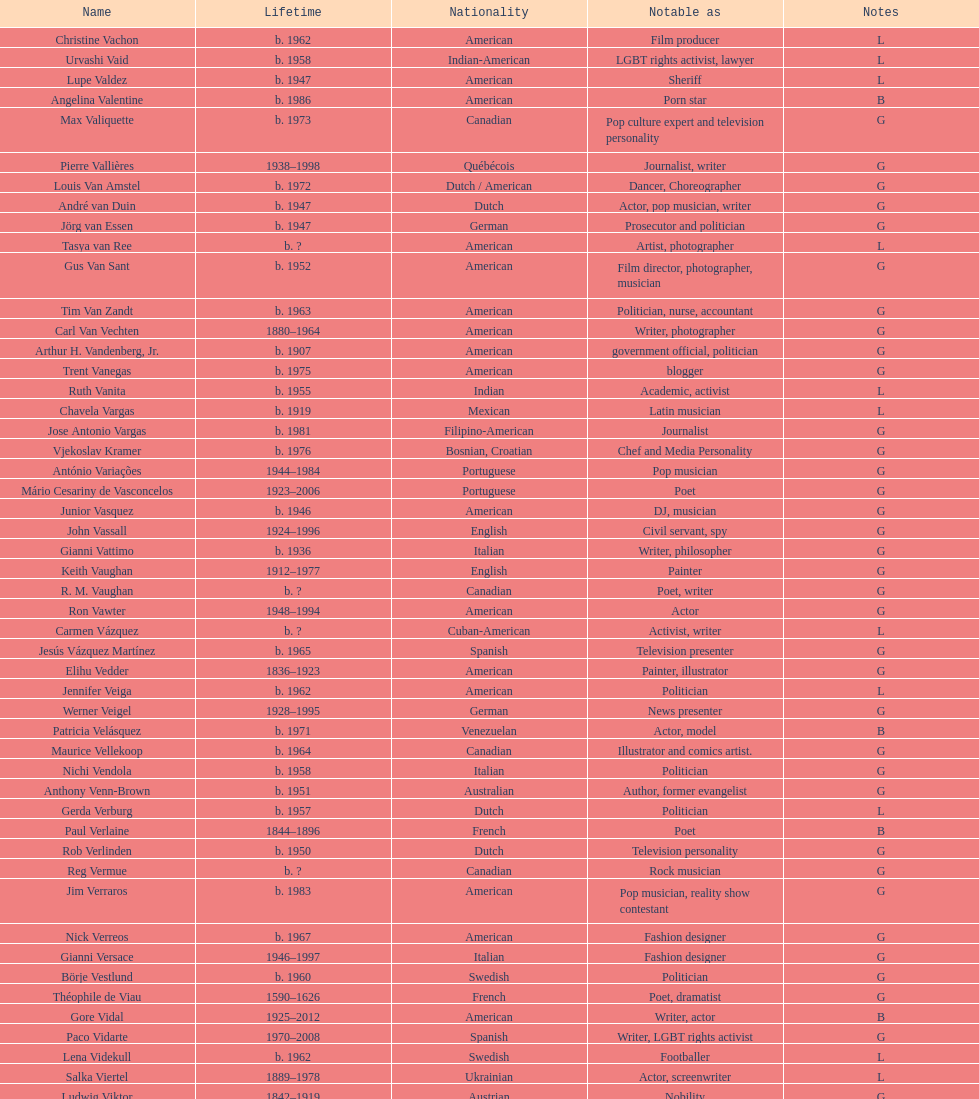Which nationality had the most notable poets? French. 